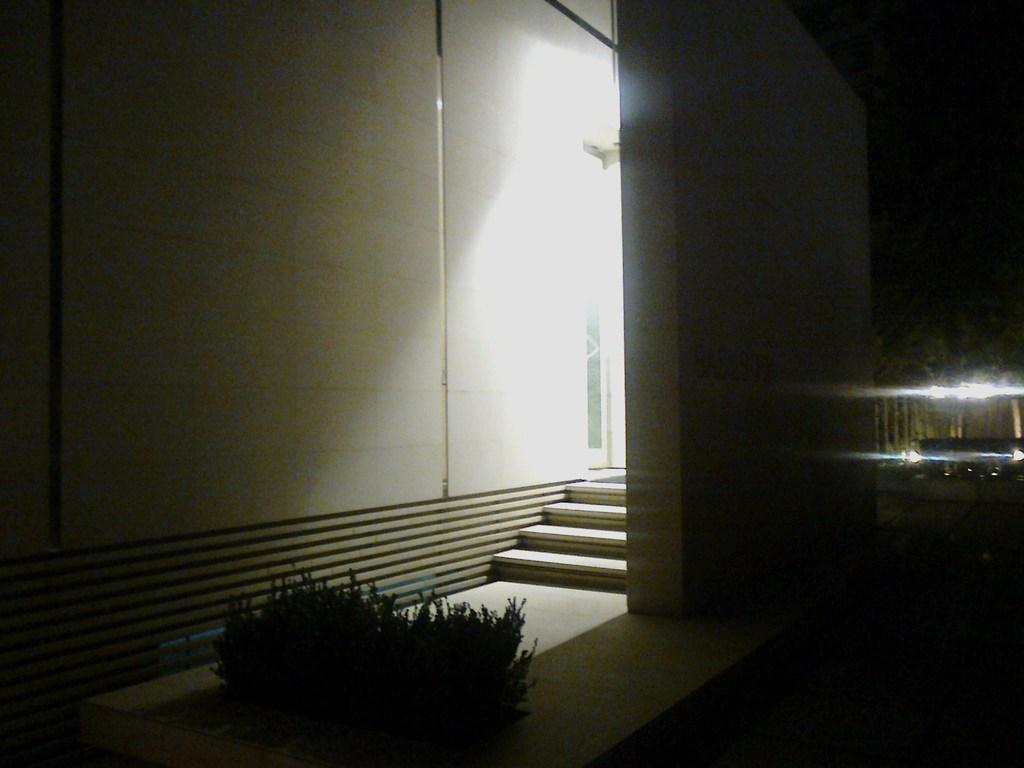Describe this image in one or two sentences. In this picture we can see the floor, plants, steps, walls, lights, some objects and in the background it is dark. 